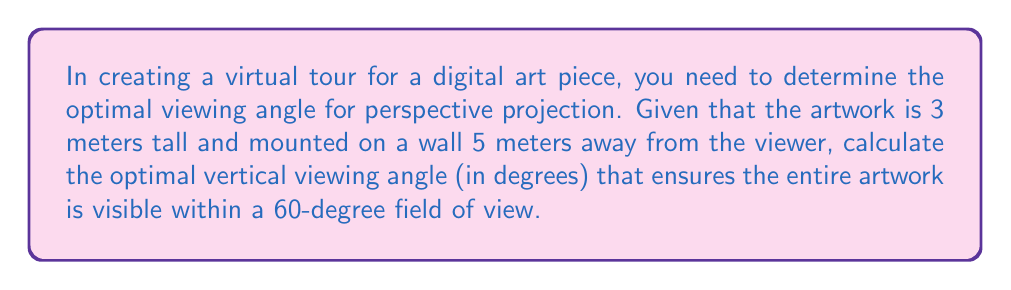Teach me how to tackle this problem. Let's approach this step-by-step:

1) First, we need to understand the geometry of the situation. We can model this as a right triangle where:
   - The base is the distance from the viewer to the wall (5 m)
   - The height is half the height of the artwork (1.5 m, as we're calculating from the center)
   - The angle we're looking for is the one formed at the viewer's eye

2) We can calculate this angle using the arctangent function:

   $$\theta = \arctan(\frac{\text{opposite}}{\text{adjacent}}) = \arctan(\frac{1.5}{5})$$

3) Let's calculate this:

   $$\theta = \arctan(0.3) \approx 0.2915 \text{ radians}$$

4) Convert radians to degrees:

   $$\theta \approx 0.2915 \times \frac{180}{\pi} \approx 16.70°$$

5) This angle represents half of our total vertical viewing angle. To get the full angle, we double it:

   $$\text{Total Vertical Angle} = 2 \times 16.70° = 33.40°$$

6) Now, we need to check if this fits within our 60-degree field of view. Since 33.40° < 60°, it does fit, and this is our optimal viewing angle.

[asy]
import geometry;

size(200);

pair A = (0,0), B = (5,0), C = (5,1.5);
draw(A--B--C--A);

label("5m", (2.5,0), S);
label("1.5m", (5,0.75), E);
label("Viewer", A, W);
label("Artwork", (5,1.5), E);

draw(arc(A,0.5,0,atan(1.5/5)*180/pi), Arrow);
label("$\theta$", (0.3,0.2));
[/asy]
Answer: 33.40° 